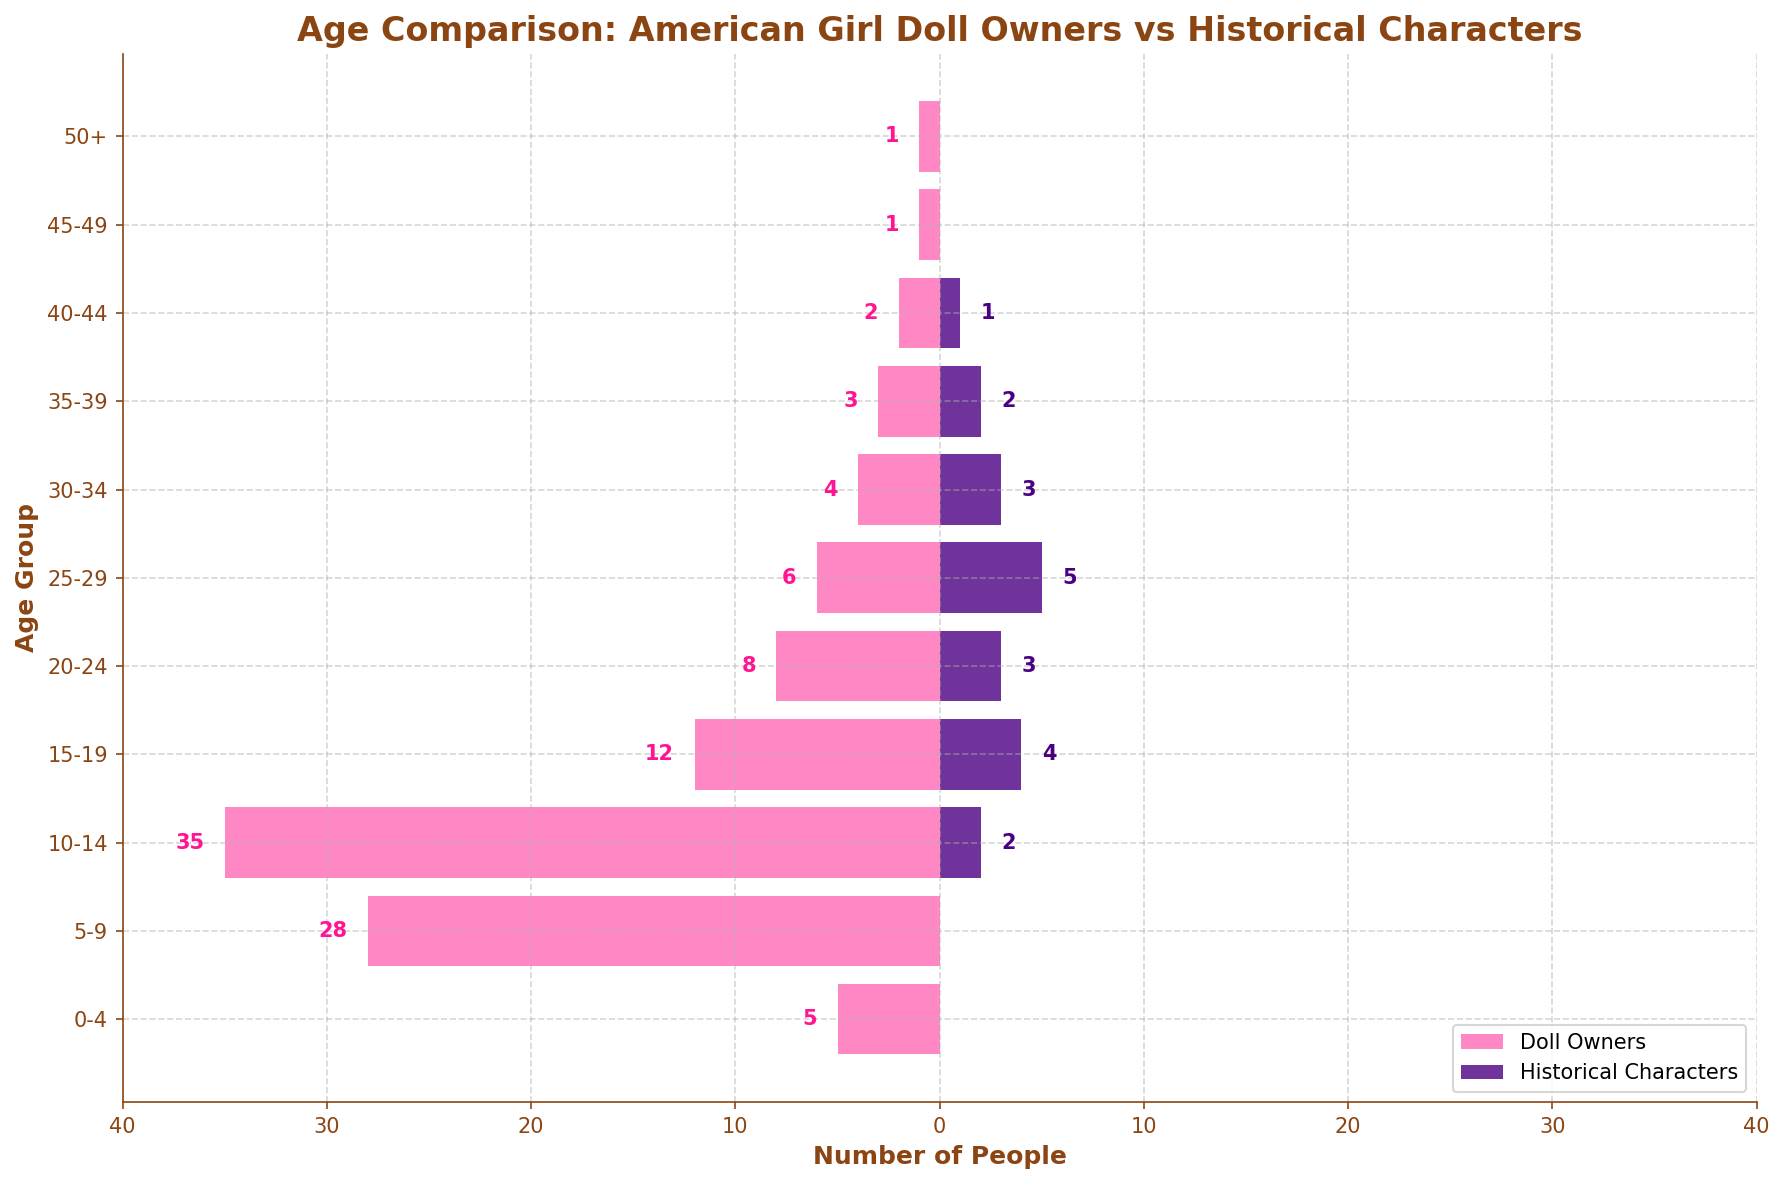What is the title of the figure? The title is displayed at the top of the figure in bold, describing the main topic of the visualization.
Answer: Age Comparison: American Girl Doll Owners vs Historical Characters What is the color used to represent Doll Owners in the figure? The color identified is used for one segment of the bars in the population pyramid.
Answer: Pink How many age groups are represented in the figure? The number of age groups can be counted by looking at the y-axis labels.
Answer: 11 What is the total number of Doll Owners in the 10-14 age group? The value can be read directly from the bar corresponding to the Doll Owners in the 10-14 age group.
Answer: 35 Which age group has the highest number of Historical Characters? By inspecting the lengths of the purple bars, we can determine the age group with the maximum number.
Answer: 25-29 Is the number of Doll Owners greater than the number of Historical Characters in the 15-19 age group? Compare the length of the pink bar (Doll Owners) and the purple bar (Historical Characters) for the 15-19 age group.
Answer: Yes What is the sum of Doll Owners aged between 20-29? Add the values from the bars representing Doll Owners in the 20-24 and 25-29 age groups (8 + 6).
Answer: 14 What is the average number of Historical Characters across all age groups displayed? Sum the numbers of Historical Characters and divide by the number of age groups (2 + 4 + 3 + 5 + 3 + 2 + 1) / 7.
Answer: 2 In which age group is the difference between Doll Owners and Historical Characters the greatest? Calculate the absolute difference between Doll Owners and Historical Characters for each age group and identify the maximum difference.
Answer: 10-14 Are there any age groups where there are Historical Characters but no Doll Owners? Inspect the bars for both Doll Owners and Historical Characters to identify any such age groups.
Answer: No 